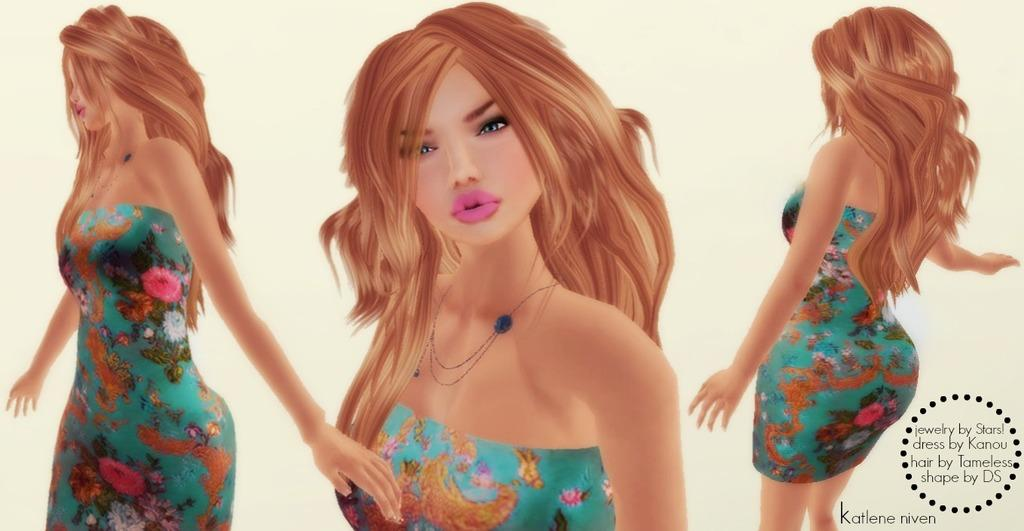What type of image is being described? The image is animated. Can you describe the main subject in the image? There is an image of a woman in the picture. Where is the text located in the image? The text is on the right side of the image. What type of bird can be seen playing with powder in the image? There is no bird or powder present in the image; it features an animated image of a woman and text on the right side. 